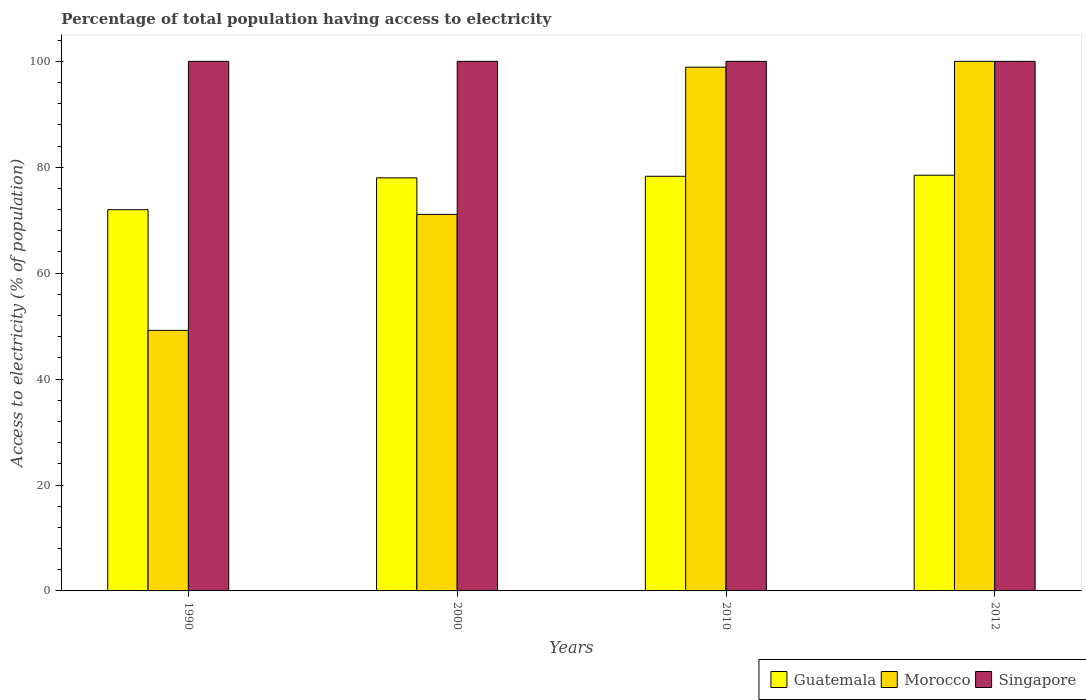How many different coloured bars are there?
Your answer should be very brief. 3. How many groups of bars are there?
Ensure brevity in your answer.  4. What is the percentage of population that have access to electricity in Singapore in 2010?
Give a very brief answer. 100. Across all years, what is the maximum percentage of population that have access to electricity in Singapore?
Ensure brevity in your answer.  100. Across all years, what is the minimum percentage of population that have access to electricity in Guatemala?
Offer a very short reply. 71.99. In which year was the percentage of population that have access to electricity in Guatemala maximum?
Provide a succinct answer. 2012. What is the total percentage of population that have access to electricity in Morocco in the graph?
Keep it short and to the point. 319.2. What is the difference between the percentage of population that have access to electricity in Morocco in 2000 and that in 2012?
Give a very brief answer. -28.9. What is the difference between the percentage of population that have access to electricity in Guatemala in 2000 and the percentage of population that have access to electricity in Morocco in 2010?
Your response must be concise. -20.9. What is the average percentage of population that have access to electricity in Morocco per year?
Make the answer very short. 79.8. In the year 1990, what is the difference between the percentage of population that have access to electricity in Singapore and percentage of population that have access to electricity in Morocco?
Offer a terse response. 50.8. In how many years, is the percentage of population that have access to electricity in Morocco greater than 16 %?
Give a very brief answer. 4. What is the ratio of the percentage of population that have access to electricity in Guatemala in 1990 to that in 2000?
Provide a short and direct response. 0.92. Is the difference between the percentage of population that have access to electricity in Singapore in 1990 and 2000 greater than the difference between the percentage of population that have access to electricity in Morocco in 1990 and 2000?
Provide a succinct answer. Yes. What is the difference between the highest and the second highest percentage of population that have access to electricity in Guatemala?
Your response must be concise. 0.2. In how many years, is the percentage of population that have access to electricity in Guatemala greater than the average percentage of population that have access to electricity in Guatemala taken over all years?
Provide a short and direct response. 3. Is the sum of the percentage of population that have access to electricity in Singapore in 1990 and 2012 greater than the maximum percentage of population that have access to electricity in Guatemala across all years?
Offer a terse response. Yes. What does the 2nd bar from the left in 2012 represents?
Ensure brevity in your answer.  Morocco. What does the 2nd bar from the right in 2012 represents?
Keep it short and to the point. Morocco. How many years are there in the graph?
Make the answer very short. 4. Are the values on the major ticks of Y-axis written in scientific E-notation?
Offer a very short reply. No. Does the graph contain any zero values?
Your response must be concise. No. Where does the legend appear in the graph?
Your answer should be very brief. Bottom right. How many legend labels are there?
Your answer should be compact. 3. What is the title of the graph?
Offer a terse response. Percentage of total population having access to electricity. What is the label or title of the Y-axis?
Provide a succinct answer. Access to electricity (% of population). What is the Access to electricity (% of population) in Guatemala in 1990?
Offer a terse response. 71.99. What is the Access to electricity (% of population) of Morocco in 1990?
Offer a very short reply. 49.2. What is the Access to electricity (% of population) in Guatemala in 2000?
Give a very brief answer. 78. What is the Access to electricity (% of population) of Morocco in 2000?
Provide a short and direct response. 71.1. What is the Access to electricity (% of population) of Guatemala in 2010?
Your answer should be compact. 78.3. What is the Access to electricity (% of population) in Morocco in 2010?
Ensure brevity in your answer.  98.9. What is the Access to electricity (% of population) in Guatemala in 2012?
Ensure brevity in your answer.  78.5. Across all years, what is the maximum Access to electricity (% of population) in Guatemala?
Keep it short and to the point. 78.5. Across all years, what is the maximum Access to electricity (% of population) in Singapore?
Your answer should be compact. 100. Across all years, what is the minimum Access to electricity (% of population) in Guatemala?
Your answer should be very brief. 71.99. Across all years, what is the minimum Access to electricity (% of population) in Morocco?
Keep it short and to the point. 49.2. What is the total Access to electricity (% of population) in Guatemala in the graph?
Ensure brevity in your answer.  306.79. What is the total Access to electricity (% of population) in Morocco in the graph?
Make the answer very short. 319.2. What is the total Access to electricity (% of population) of Singapore in the graph?
Give a very brief answer. 400. What is the difference between the Access to electricity (% of population) of Guatemala in 1990 and that in 2000?
Give a very brief answer. -6.01. What is the difference between the Access to electricity (% of population) in Morocco in 1990 and that in 2000?
Give a very brief answer. -21.9. What is the difference between the Access to electricity (% of population) in Singapore in 1990 and that in 2000?
Ensure brevity in your answer.  0. What is the difference between the Access to electricity (% of population) in Guatemala in 1990 and that in 2010?
Make the answer very short. -6.31. What is the difference between the Access to electricity (% of population) of Morocco in 1990 and that in 2010?
Give a very brief answer. -49.7. What is the difference between the Access to electricity (% of population) of Guatemala in 1990 and that in 2012?
Your answer should be compact. -6.51. What is the difference between the Access to electricity (% of population) in Morocco in 1990 and that in 2012?
Give a very brief answer. -50.8. What is the difference between the Access to electricity (% of population) in Singapore in 1990 and that in 2012?
Provide a succinct answer. 0. What is the difference between the Access to electricity (% of population) of Morocco in 2000 and that in 2010?
Give a very brief answer. -27.8. What is the difference between the Access to electricity (% of population) of Singapore in 2000 and that in 2010?
Make the answer very short. 0. What is the difference between the Access to electricity (% of population) of Guatemala in 2000 and that in 2012?
Give a very brief answer. -0.5. What is the difference between the Access to electricity (% of population) in Morocco in 2000 and that in 2012?
Your answer should be compact. -28.9. What is the difference between the Access to electricity (% of population) in Singapore in 2000 and that in 2012?
Provide a short and direct response. 0. What is the difference between the Access to electricity (% of population) of Guatemala in 1990 and the Access to electricity (% of population) of Morocco in 2000?
Make the answer very short. 0.89. What is the difference between the Access to electricity (% of population) in Guatemala in 1990 and the Access to electricity (% of population) in Singapore in 2000?
Keep it short and to the point. -28.01. What is the difference between the Access to electricity (% of population) of Morocco in 1990 and the Access to electricity (% of population) of Singapore in 2000?
Your answer should be compact. -50.8. What is the difference between the Access to electricity (% of population) in Guatemala in 1990 and the Access to electricity (% of population) in Morocco in 2010?
Offer a very short reply. -26.91. What is the difference between the Access to electricity (% of population) in Guatemala in 1990 and the Access to electricity (% of population) in Singapore in 2010?
Provide a short and direct response. -28.01. What is the difference between the Access to electricity (% of population) of Morocco in 1990 and the Access to electricity (% of population) of Singapore in 2010?
Offer a very short reply. -50.8. What is the difference between the Access to electricity (% of population) in Guatemala in 1990 and the Access to electricity (% of population) in Morocco in 2012?
Provide a succinct answer. -28.01. What is the difference between the Access to electricity (% of population) of Guatemala in 1990 and the Access to electricity (% of population) of Singapore in 2012?
Ensure brevity in your answer.  -28.01. What is the difference between the Access to electricity (% of population) in Morocco in 1990 and the Access to electricity (% of population) in Singapore in 2012?
Offer a very short reply. -50.8. What is the difference between the Access to electricity (% of population) in Guatemala in 2000 and the Access to electricity (% of population) in Morocco in 2010?
Provide a short and direct response. -20.9. What is the difference between the Access to electricity (% of population) of Morocco in 2000 and the Access to electricity (% of population) of Singapore in 2010?
Offer a terse response. -28.9. What is the difference between the Access to electricity (% of population) of Guatemala in 2000 and the Access to electricity (% of population) of Morocco in 2012?
Give a very brief answer. -22. What is the difference between the Access to electricity (% of population) in Guatemala in 2000 and the Access to electricity (% of population) in Singapore in 2012?
Ensure brevity in your answer.  -22. What is the difference between the Access to electricity (% of population) in Morocco in 2000 and the Access to electricity (% of population) in Singapore in 2012?
Your response must be concise. -28.9. What is the difference between the Access to electricity (% of population) in Guatemala in 2010 and the Access to electricity (% of population) in Morocco in 2012?
Provide a short and direct response. -21.7. What is the difference between the Access to electricity (% of population) of Guatemala in 2010 and the Access to electricity (% of population) of Singapore in 2012?
Offer a very short reply. -21.7. What is the average Access to electricity (% of population) of Guatemala per year?
Make the answer very short. 76.7. What is the average Access to electricity (% of population) in Morocco per year?
Offer a very short reply. 79.8. What is the average Access to electricity (% of population) of Singapore per year?
Give a very brief answer. 100. In the year 1990, what is the difference between the Access to electricity (% of population) in Guatemala and Access to electricity (% of population) in Morocco?
Keep it short and to the point. 22.79. In the year 1990, what is the difference between the Access to electricity (% of population) of Guatemala and Access to electricity (% of population) of Singapore?
Provide a succinct answer. -28.01. In the year 1990, what is the difference between the Access to electricity (% of population) of Morocco and Access to electricity (% of population) of Singapore?
Your answer should be compact. -50.8. In the year 2000, what is the difference between the Access to electricity (% of population) in Morocco and Access to electricity (% of population) in Singapore?
Offer a terse response. -28.9. In the year 2010, what is the difference between the Access to electricity (% of population) in Guatemala and Access to electricity (% of population) in Morocco?
Your answer should be very brief. -20.6. In the year 2010, what is the difference between the Access to electricity (% of population) in Guatemala and Access to electricity (% of population) in Singapore?
Keep it short and to the point. -21.7. In the year 2010, what is the difference between the Access to electricity (% of population) of Morocco and Access to electricity (% of population) of Singapore?
Ensure brevity in your answer.  -1.1. In the year 2012, what is the difference between the Access to electricity (% of population) of Guatemala and Access to electricity (% of population) of Morocco?
Make the answer very short. -21.5. In the year 2012, what is the difference between the Access to electricity (% of population) of Guatemala and Access to electricity (% of population) of Singapore?
Ensure brevity in your answer.  -21.5. What is the ratio of the Access to electricity (% of population) of Guatemala in 1990 to that in 2000?
Offer a terse response. 0.92. What is the ratio of the Access to electricity (% of population) of Morocco in 1990 to that in 2000?
Give a very brief answer. 0.69. What is the ratio of the Access to electricity (% of population) in Singapore in 1990 to that in 2000?
Give a very brief answer. 1. What is the ratio of the Access to electricity (% of population) in Guatemala in 1990 to that in 2010?
Provide a short and direct response. 0.92. What is the ratio of the Access to electricity (% of population) of Morocco in 1990 to that in 2010?
Provide a succinct answer. 0.5. What is the ratio of the Access to electricity (% of population) in Guatemala in 1990 to that in 2012?
Your response must be concise. 0.92. What is the ratio of the Access to electricity (% of population) of Morocco in 1990 to that in 2012?
Your response must be concise. 0.49. What is the ratio of the Access to electricity (% of population) in Singapore in 1990 to that in 2012?
Provide a short and direct response. 1. What is the ratio of the Access to electricity (% of population) of Guatemala in 2000 to that in 2010?
Offer a very short reply. 1. What is the ratio of the Access to electricity (% of population) of Morocco in 2000 to that in 2010?
Offer a very short reply. 0.72. What is the ratio of the Access to electricity (% of population) of Morocco in 2000 to that in 2012?
Ensure brevity in your answer.  0.71. What is the ratio of the Access to electricity (% of population) in Morocco in 2010 to that in 2012?
Provide a succinct answer. 0.99. What is the ratio of the Access to electricity (% of population) in Singapore in 2010 to that in 2012?
Give a very brief answer. 1. What is the difference between the highest and the second highest Access to electricity (% of population) in Singapore?
Your response must be concise. 0. What is the difference between the highest and the lowest Access to electricity (% of population) in Guatemala?
Provide a short and direct response. 6.51. What is the difference between the highest and the lowest Access to electricity (% of population) of Morocco?
Provide a short and direct response. 50.8. What is the difference between the highest and the lowest Access to electricity (% of population) of Singapore?
Your response must be concise. 0. 